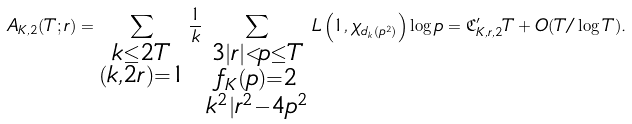Convert formula to latex. <formula><loc_0><loc_0><loc_500><loc_500>A _ { K , 2 } ( T ; r ) = \sum _ { \substack { k \leq 2 T \\ ( k , 2 r ) = 1 } } \frac { 1 } { k } \sum _ { \substack { 3 | r | < p \leq T \\ f _ { K } ( p ) = 2 \\ k ^ { 2 } | r ^ { 2 } - 4 p ^ { 2 } } } L \left ( 1 , \chi _ { d _ { k } ( p ^ { 2 } ) } \right ) \log p = \mathfrak C _ { K , r , 2 } ^ { \prime } T + O ( T / \log T ) .</formula> 